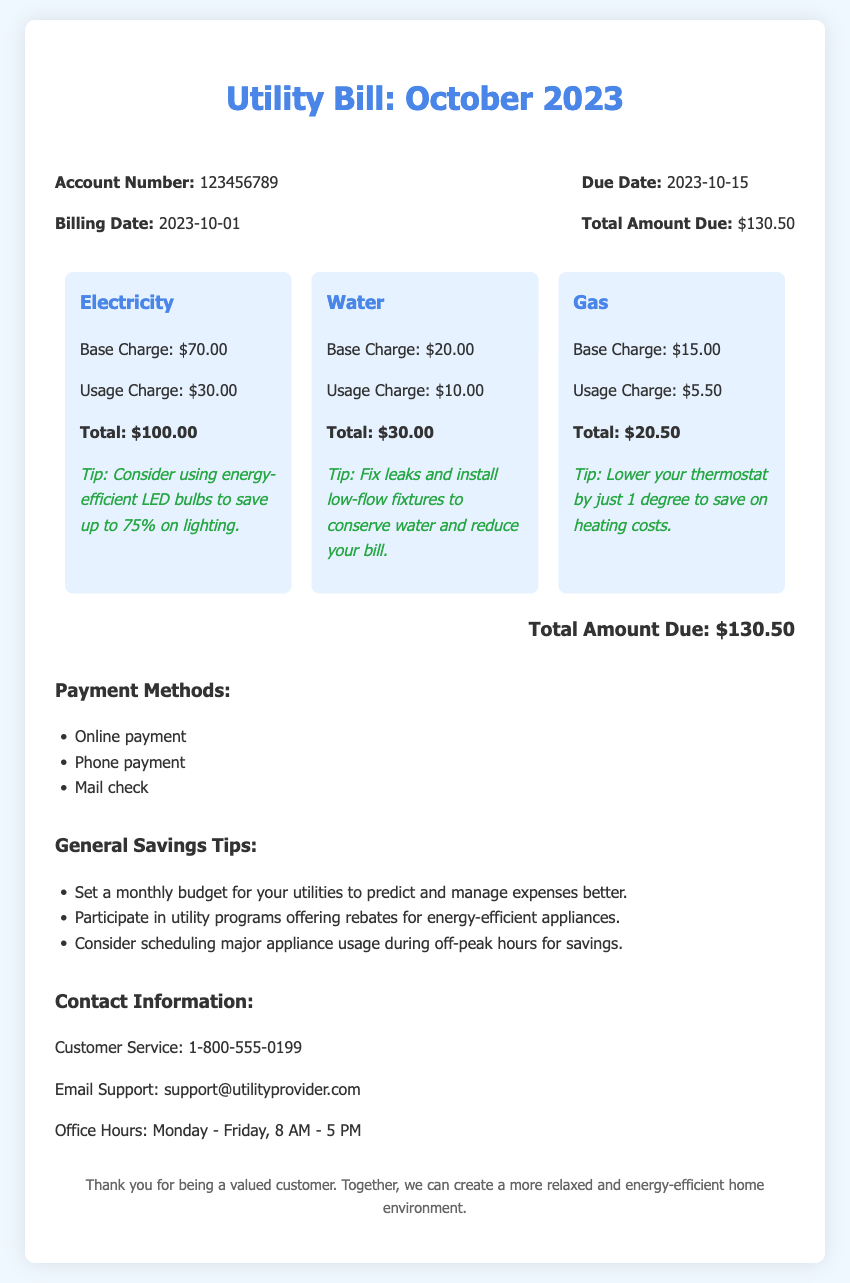What is the account number? The account number is a unique identifier for the utility bill, which is 123456789.
Answer: 123456789 What is the total amount due? The total amount due is the final amount highlighted in the document, which is $130.50.
Answer: $130.50 What is the billing date? The billing date indicates when the bill was issued, which is 2023-10-01.
Answer: 2023-10-01 What is the base charge for electricity? The base charge for electricity is listed separately, which is $70.00.
Answer: $70.00 How can we save on gas costs? Suggested savings for gas costs is to lower the thermostat by just 1 degree.
Answer: Lower the thermostat by 1 degree How much is the total charge for water? The total charge for water can be determined by adding the base and usage charge, which equals $30.00.
Answer: $30.00 When is the due date? The due date indicates when the payment needs to be made, which is 2023-10-15.
Answer: 2023-10-15 What are the payment methods listed? The document specifies multiple payment methods available to customers, such as online payment, phone payment, and mail check.
Answer: Online payment, phone payment, mail check What is one general savings tip mentioned? One of the general savings tips encourages setting a monthly budget for utilities to manage expenses better.
Answer: Set a monthly budget for your utilities 